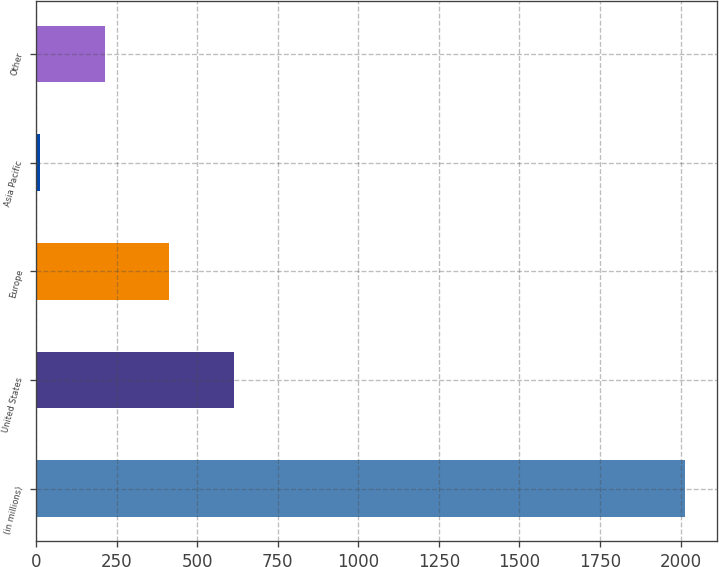<chart> <loc_0><loc_0><loc_500><loc_500><bar_chart><fcel>(in millions)<fcel>United States<fcel>Europe<fcel>Asia Pacific<fcel>Other<nl><fcel>2013<fcel>612.3<fcel>412.2<fcel>12<fcel>212.1<nl></chart> 